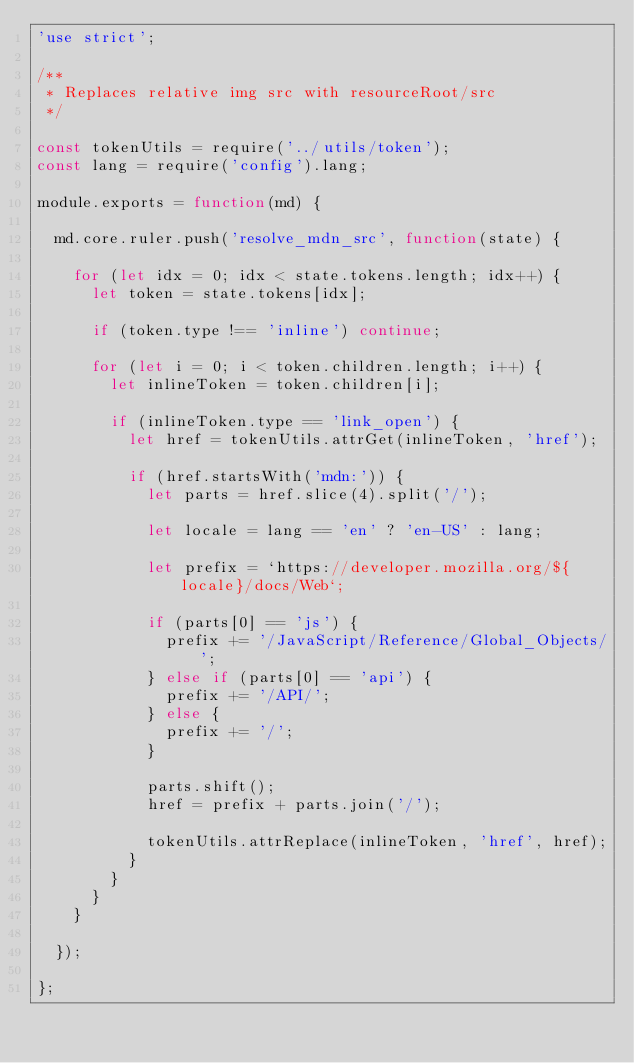<code> <loc_0><loc_0><loc_500><loc_500><_JavaScript_>'use strict';

/**
 * Replaces relative img src with resourceRoot/src
 */

const tokenUtils = require('../utils/token');
const lang = require('config').lang;

module.exports = function(md) {

  md.core.ruler.push('resolve_mdn_src', function(state) {

    for (let idx = 0; idx < state.tokens.length; idx++) {
      let token = state.tokens[idx];

      if (token.type !== 'inline') continue;

      for (let i = 0; i < token.children.length; i++) {
        let inlineToken = token.children[i];

        if (inlineToken.type == 'link_open') {
          let href = tokenUtils.attrGet(inlineToken, 'href');

          if (href.startsWith('mdn:')) {
            let parts = href.slice(4).split('/');

            let locale = lang == 'en' ? 'en-US' : lang;

            let prefix = `https://developer.mozilla.org/${locale}/docs/Web`;

            if (parts[0] == 'js') {
              prefix += '/JavaScript/Reference/Global_Objects/';
            } else if (parts[0] == 'api') {
              prefix += '/API/';
            } else {
              prefix += '/';
            }

            parts.shift();
            href = prefix + parts.join('/');

            tokenUtils.attrReplace(inlineToken, 'href', href);
          }
        }
      }
    }

  });

};
</code> 